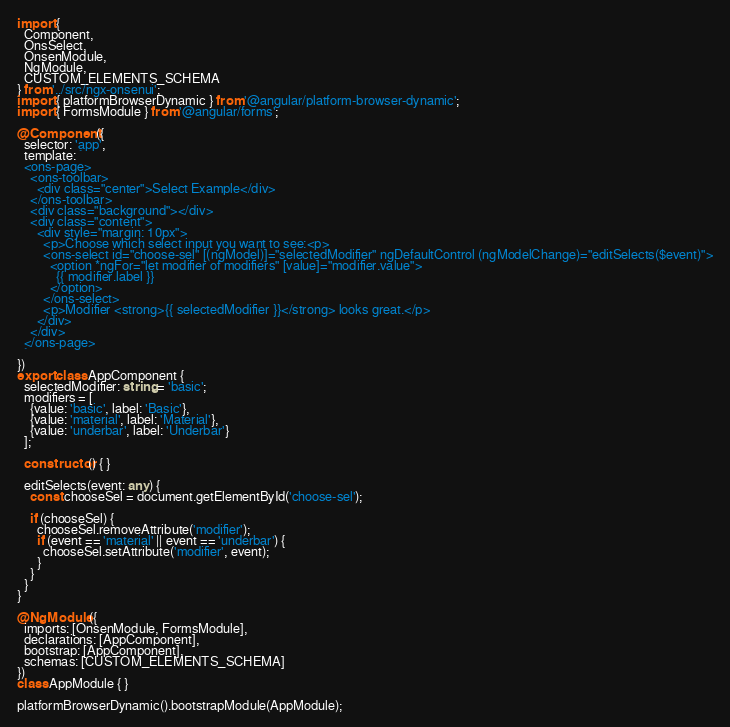<code> <loc_0><loc_0><loc_500><loc_500><_TypeScript_>import {
  Component,
  OnsSelect,
  OnsenModule,
  NgModule,
  CUSTOM_ELEMENTS_SCHEMA
} from '../src/ngx-onsenui';
import { platformBrowserDynamic } from '@angular/platform-browser-dynamic';
import { FormsModule } from '@angular/forms';

@Component({
  selector: 'app',
  template: `
  <ons-page>
    <ons-toolbar>
      <div class="center">Select Example</div>
    </ons-toolbar>
    <div class="background"></div>
    <div class="content">
      <div style="margin: 10px">
        <p>Choose which select input you want to see:<p>
        <ons-select id="choose-sel" [(ngModel)]="selectedModifier" ngDefaultControl (ngModelChange)="editSelects($event)">
          <option *ngFor="let modifier of modifiers" [value]="modifier.value">
            {{ modifier.label }}
          </option>
        </ons-select>
        <p>Modifier <strong>{{ selectedModifier }}</strong> looks great.</p>
      </div>
    </div>
  </ons-page>
  `
})
export class AppComponent {
  selectedModifier: string = 'basic';
  modifiers = [
    {value: 'basic', label: 'Basic'},
    {value: 'material', label: 'Material'},
    {value: 'underbar', label: 'Underbar'}
  ];

  constructor() { }

  editSelects(event: any) {
    const chooseSel = document.getElementById('choose-sel');

    if (chooseSel) {
      chooseSel.removeAttribute('modifier');
      if (event == 'material' || event == 'underbar') {
        chooseSel.setAttribute('modifier', event);
      }
    }
  }
}

@NgModule({
  imports: [OnsenModule, FormsModule],
  declarations: [AppComponent],
  bootstrap: [AppComponent],
  schemas: [CUSTOM_ELEMENTS_SCHEMA]
})
class AppModule { }

platformBrowserDynamic().bootstrapModule(AppModule);
</code> 